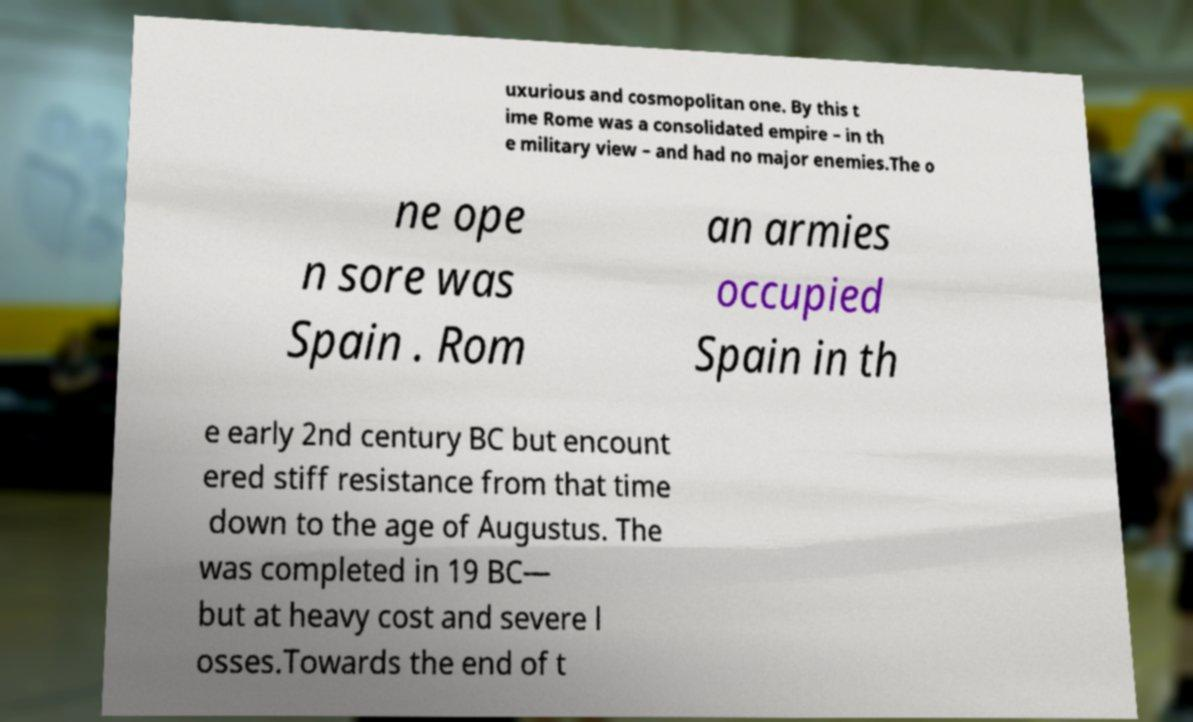Can you accurately transcribe the text from the provided image for me? uxurious and cosmopolitan one. By this t ime Rome was a consolidated empire – in th e military view – and had no major enemies.The o ne ope n sore was Spain . Rom an armies occupied Spain in th e early 2nd century BC but encount ered stiff resistance from that time down to the age of Augustus. The was completed in 19 BC— but at heavy cost and severe l osses.Towards the end of t 